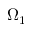Convert formula to latex. <formula><loc_0><loc_0><loc_500><loc_500>\Omega _ { 1 }</formula> 